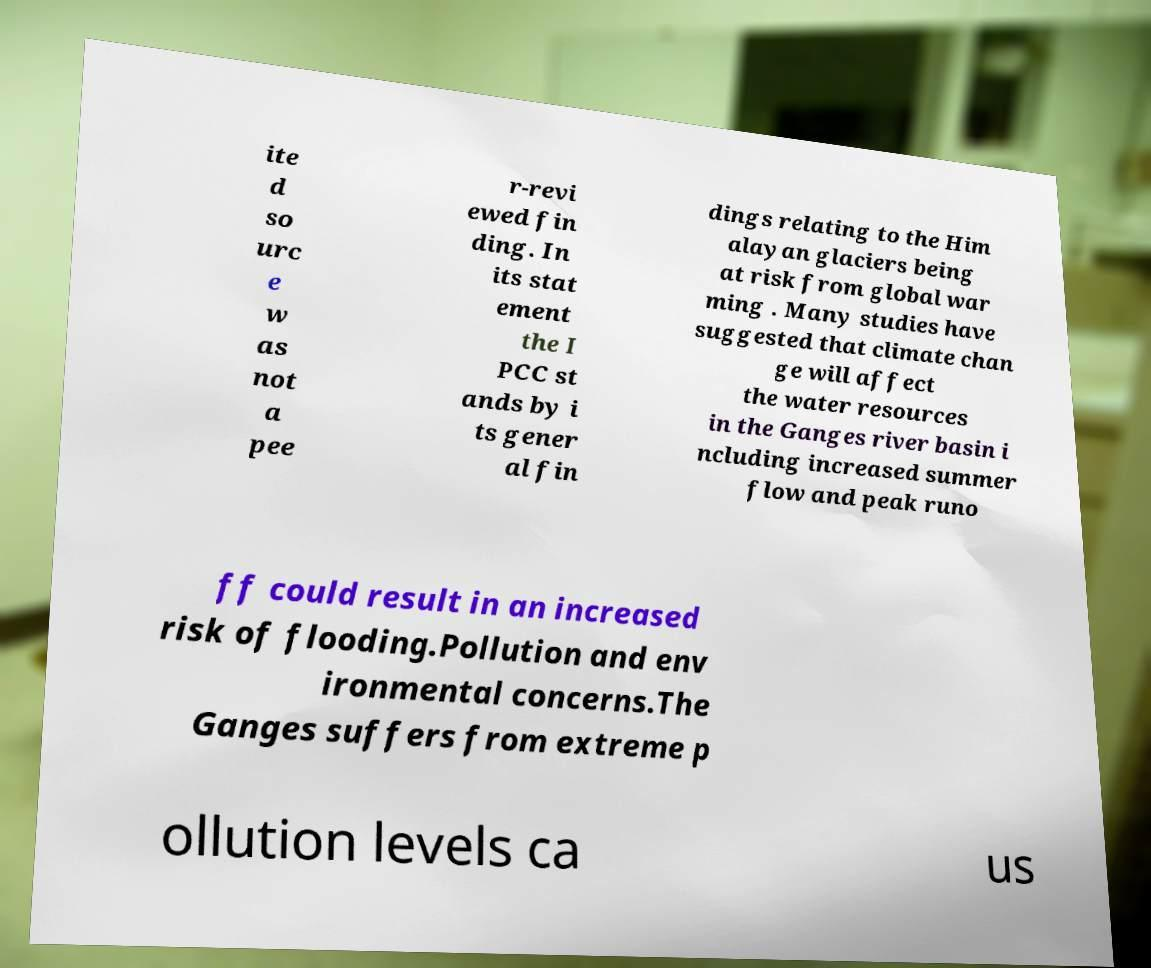For documentation purposes, I need the text within this image transcribed. Could you provide that? ite d so urc e w as not a pee r-revi ewed fin ding. In its stat ement the I PCC st ands by i ts gener al fin dings relating to the Him alayan glaciers being at risk from global war ming . Many studies have suggested that climate chan ge will affect the water resources in the Ganges river basin i ncluding increased summer flow and peak runo ff could result in an increased risk of flooding.Pollution and env ironmental concerns.The Ganges suffers from extreme p ollution levels ca us 